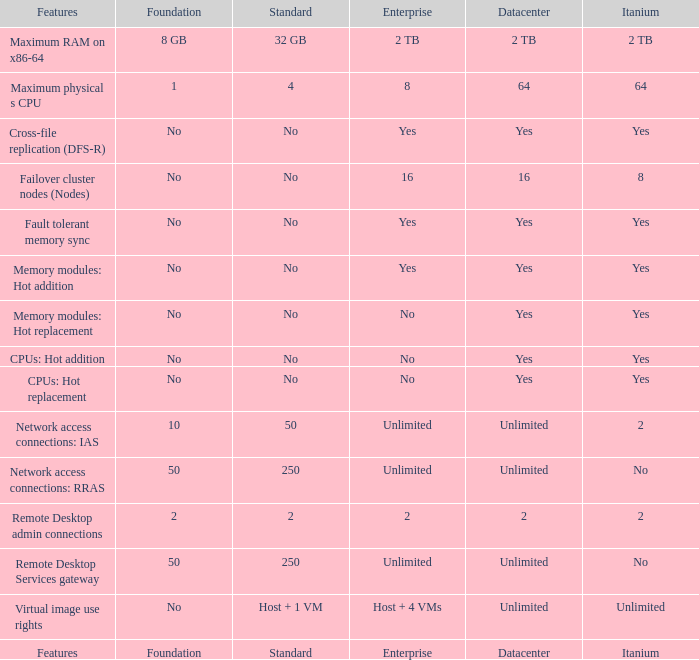What Datacenter is listed against the network access connections: rras Feature? Unlimited. 